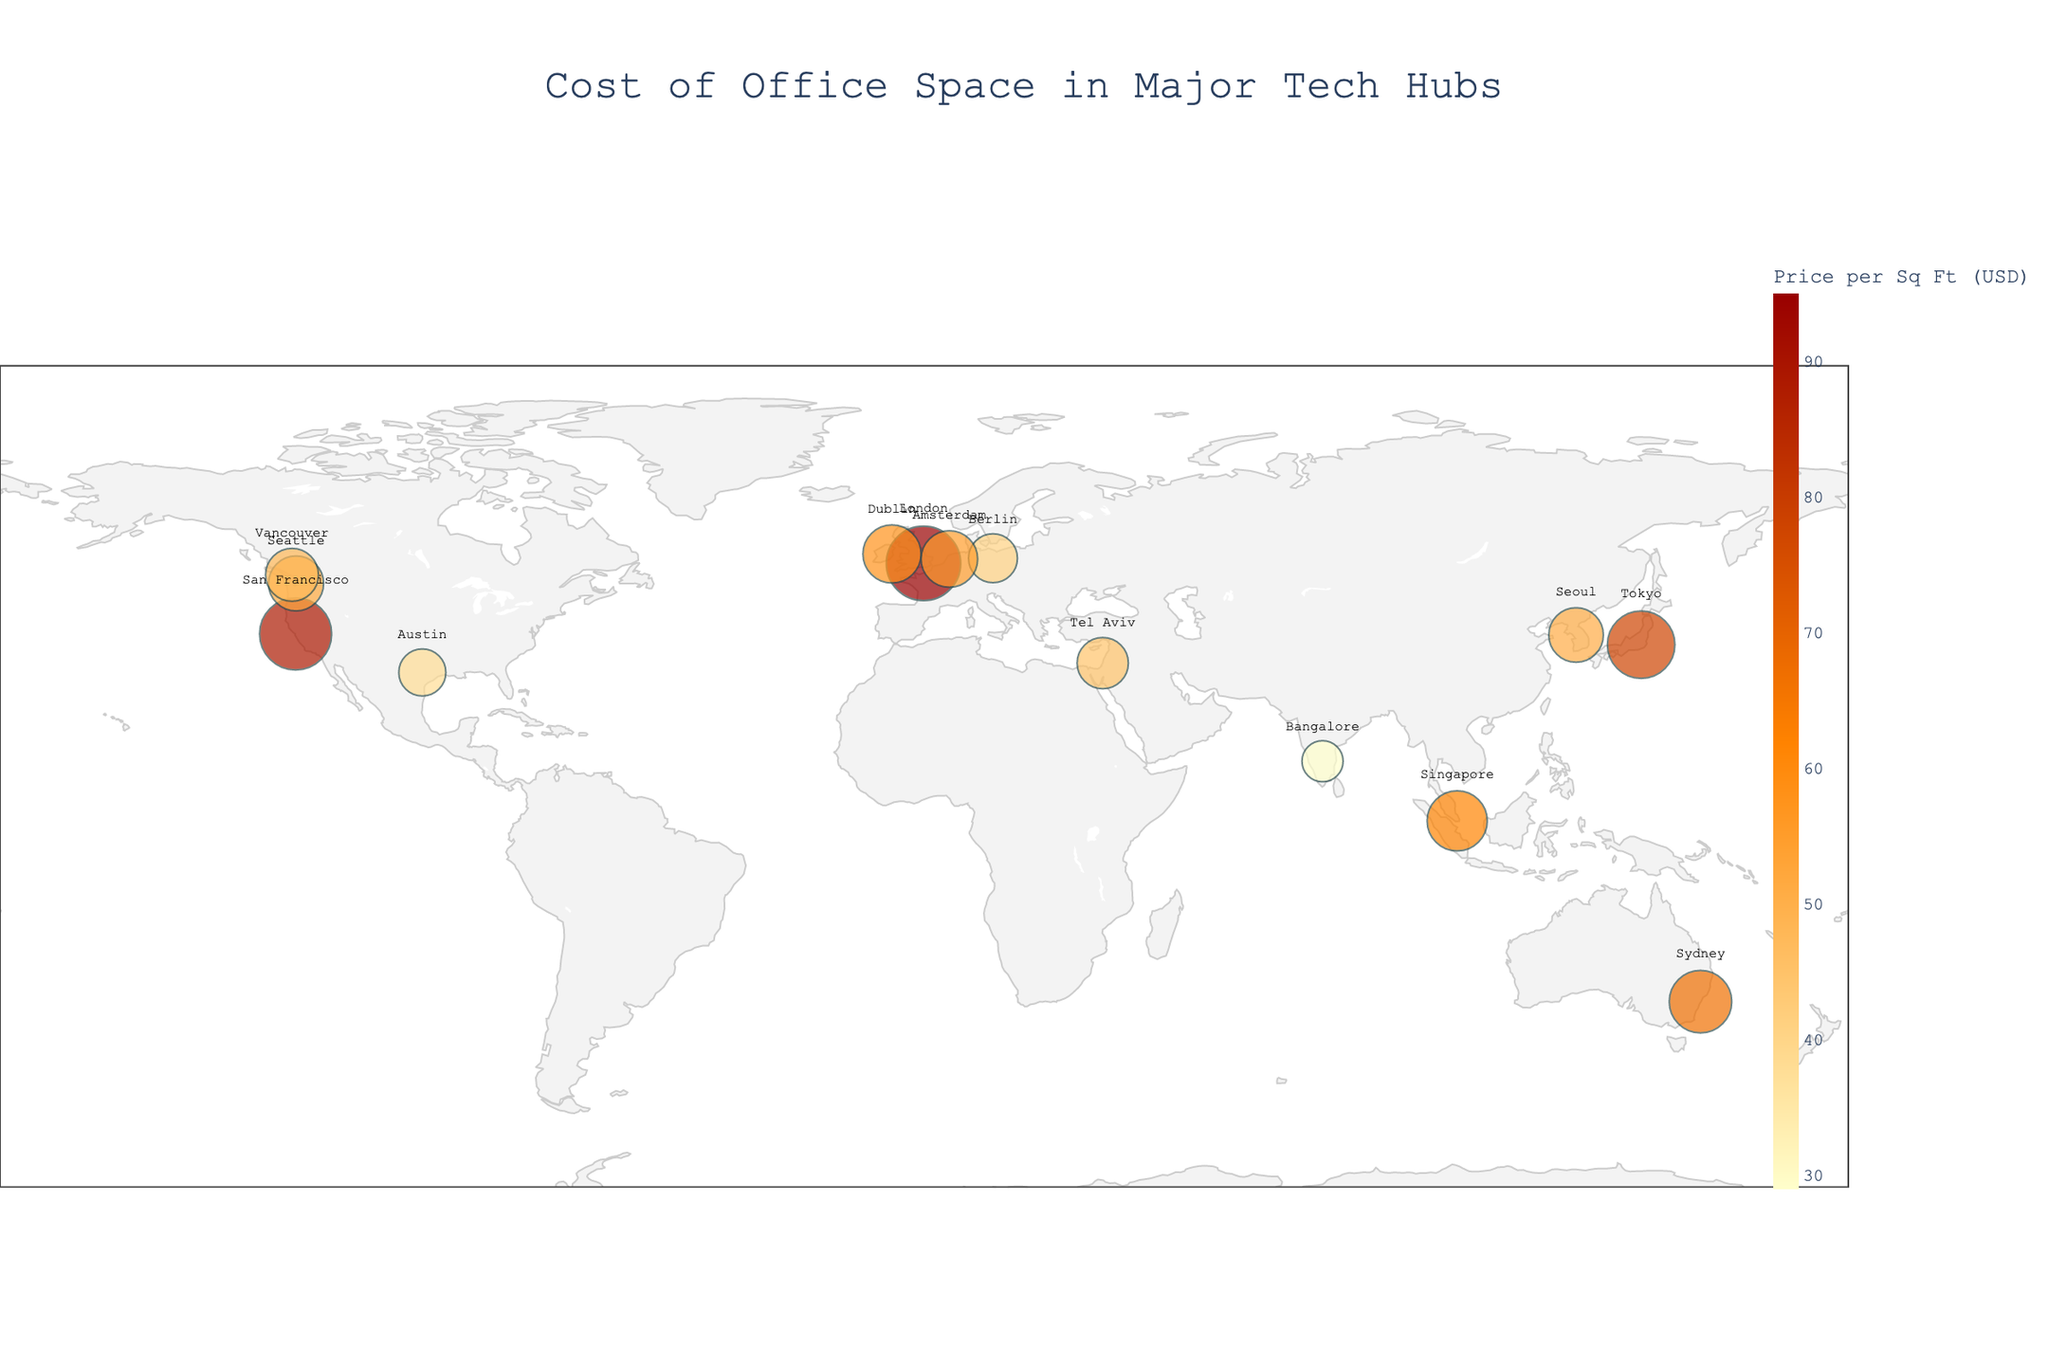What is the title of the plot? The title is typically displayed at the top of the plot. It provides a summary of what the plot represents.
Answer: Cost of Office Space in Major Tech Hubs Which city has the highest price per square foot? By examining the color intensity and size of the markers, the highest price per square foot will be identified by the most prominent and intense marker.
Answer: London What is the price per square foot of office space in Tokyo? By hovering over the data point for Tokyo, you can see the exact price per square foot.
Answer: 78 USD How many cities have a price per square foot of 50 USD or more? By counting the number of markers with colors that correspond to 50 USD or more, this can be deduced.
Answer: 9 cities Which city is the cheapest for office space among those listed? By identifying the smallest and least intense marker, you can determine the city with the lowest price per square foot.
Answer: Bangalore What is the difference in price per square foot between San Francisco and Seattle? Subtract the price per square foot of Seattle from that of San Francisco.
Answer: 37 USD Which two cities have the closest prices per square foot, and what are those prices? Identify the cities with the most similar marker sizes and colors.
Answer: Seattle (52 USD) and Seoul (51 USD) What is the average price per square foot for all the cities listed? Sum each city's price per square foot and then divide by the number of cities. (89 + 78 + 95 + 52 + 41 + 38 + 45 + 62 + 55 + 48 + 58 + 29 + 51 + 67) / 14
Answer: 57 USD Which countries are represented in the plot? Read the country labels provided in the plot.
Answer: USA, Japan, UK, Germany, Israel, Singapore, Netherlands, Canada, Ireland, India, South Korea, Australia Which tech hub is closest to the origin (0, 0) in terms of latitude and longitude? By examining the plot's geography and the proximity of markers to the origin (0, 0), determine the nearest city.
Answer: Singapore 